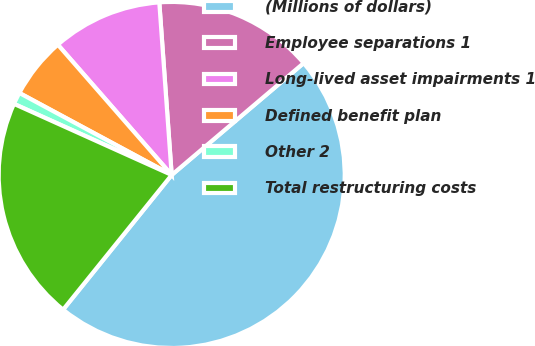Convert chart. <chart><loc_0><loc_0><loc_500><loc_500><pie_chart><fcel>(Millions of dollars)<fcel>Employee separations 1<fcel>Long-lived asset impairments 1<fcel>Defined benefit plan<fcel>Other 2<fcel>Total restructuring costs<nl><fcel>46.99%<fcel>14.95%<fcel>10.29%<fcel>5.71%<fcel>1.12%<fcel>20.94%<nl></chart> 